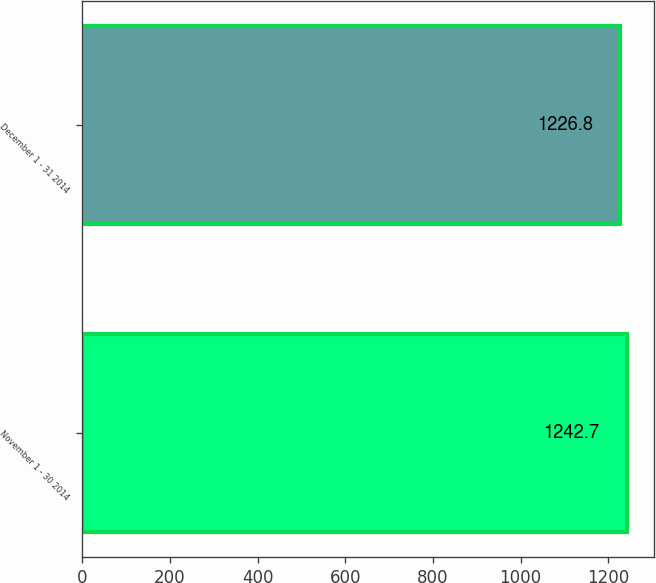Convert chart to OTSL. <chart><loc_0><loc_0><loc_500><loc_500><bar_chart><fcel>November 1 - 30 2014<fcel>December 1 - 31 2014<nl><fcel>1242.7<fcel>1226.8<nl></chart> 